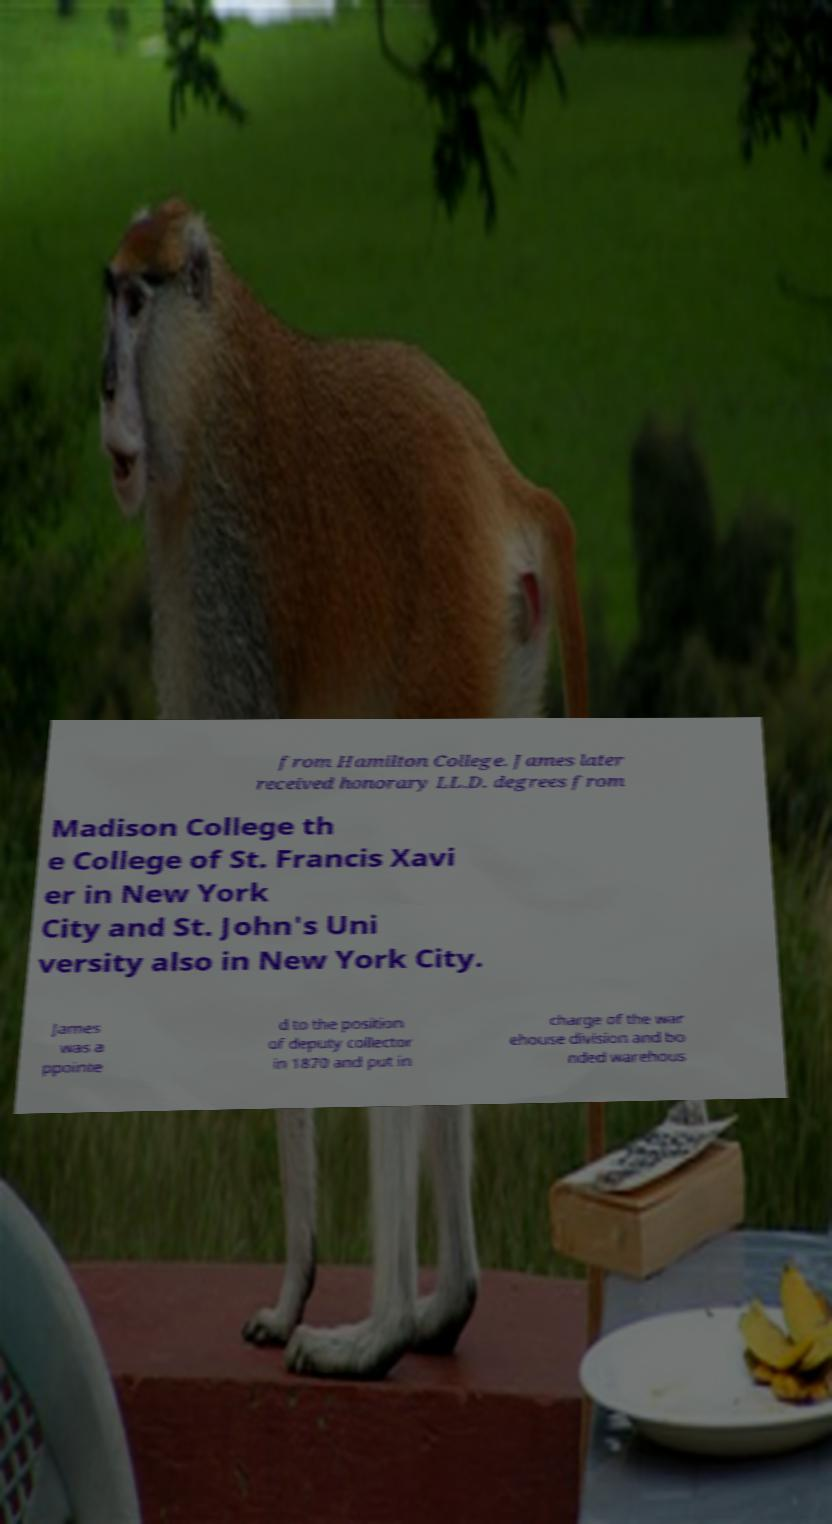What messages or text are displayed in this image? I need them in a readable, typed format. from Hamilton College. James later received honorary LL.D. degrees from Madison College th e College of St. Francis Xavi er in New York City and St. John's Uni versity also in New York City. James was a ppointe d to the position of deputy collector in 1870 and put in charge of the war ehouse division and bo nded warehous 